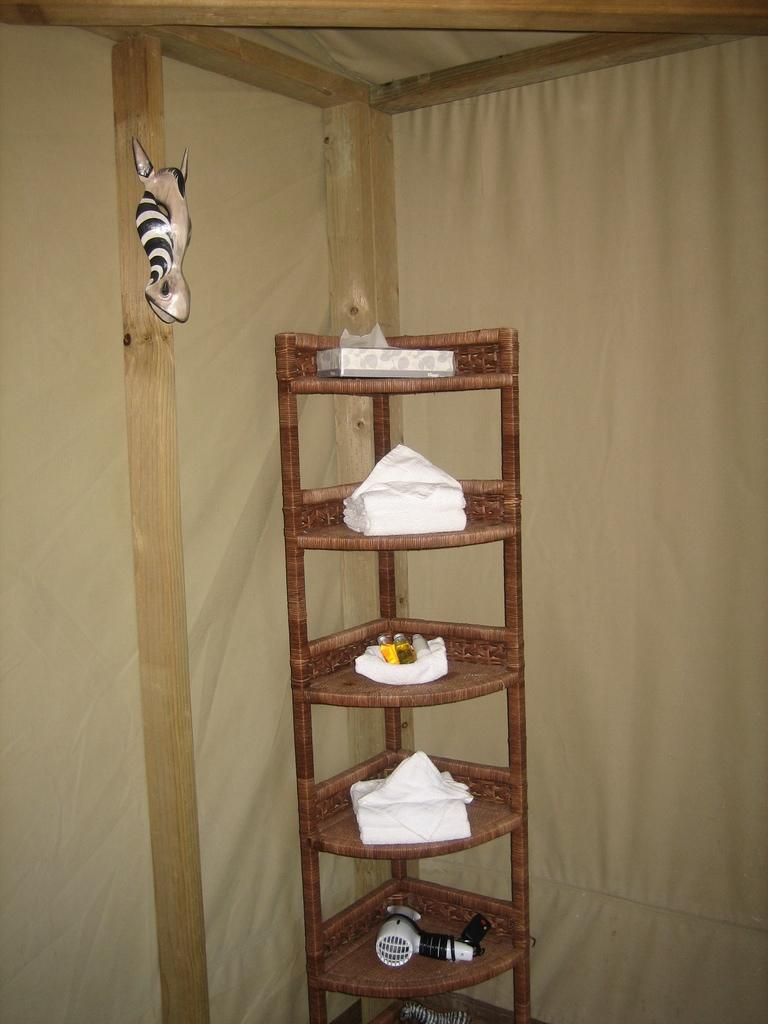What is the main object in the image? There is a box in the image. What else can be seen inside the box? Tissue papers are visible in the image. Are there any other items in the image besides the box? Yes, there are bottles and a hair dryer in the image. How are the objects arranged in the image? The objects are placed in racks. What decorative element is present in the image? There is a decor on a wooden pole in the image. Is there any covering or barrier in the image? Yes, there is a curtain in the image. What type of loaf is being cooked in the image? There is no loaf or cooking activity present in the image. What attraction can be seen in the image? There is no attraction or tourist destination depicted in the image. 